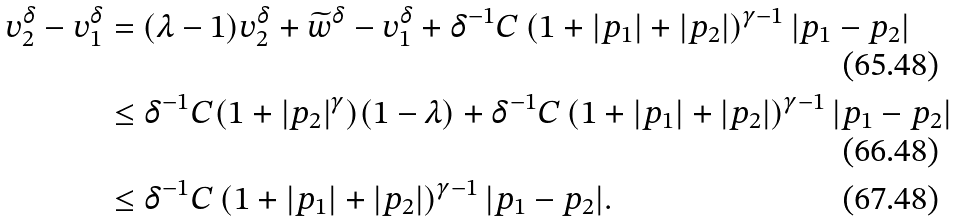Convert formula to latex. <formula><loc_0><loc_0><loc_500><loc_500>v ^ { \delta } _ { 2 } - v ^ { \delta } _ { 1 } & = ( \lambda - 1 ) v ^ { \delta } _ { 2 } + \widetilde { w } ^ { \delta } - v ^ { \delta } _ { 1 } + \delta ^ { - 1 } C \left ( 1 + | p _ { 1 } | + | p _ { 2 } | \right ) ^ { \gamma - 1 } | p _ { 1 } - p _ { 2 } | \\ & \leq \delta ^ { - 1 } C ( 1 + | p _ { 2 } | ^ { \gamma } ) ( 1 - \lambda ) + \delta ^ { - 1 } C \left ( 1 + | p _ { 1 } | + | p _ { 2 } | \right ) ^ { \gamma - 1 } | p _ { 1 } - p _ { 2 } | \\ & \leq \delta ^ { - 1 } C \left ( 1 + | p _ { 1 } | + | p _ { 2 } | \right ) ^ { \gamma - 1 } | p _ { 1 } - p _ { 2 } | .</formula> 